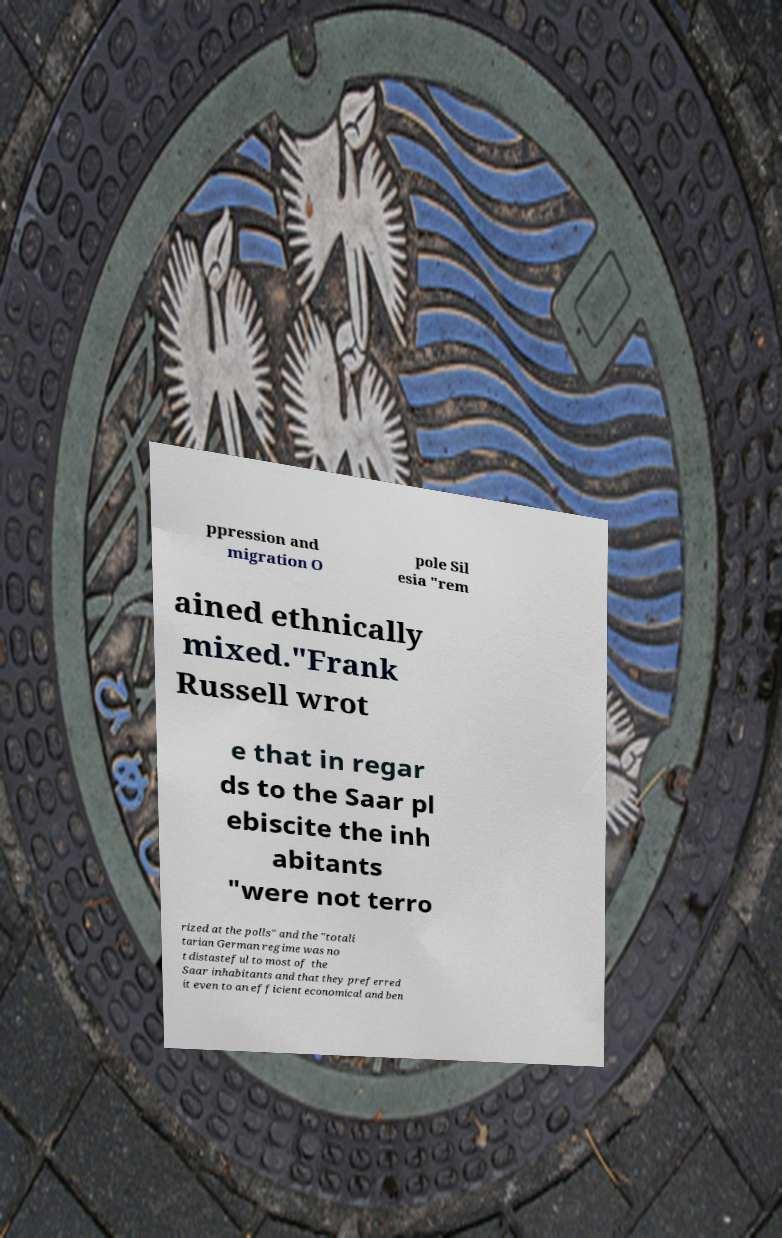Can you read and provide the text displayed in the image?This photo seems to have some interesting text. Can you extract and type it out for me? ppression and migration O pole Sil esia "rem ained ethnically mixed."Frank Russell wrot e that in regar ds to the Saar pl ebiscite the inh abitants "were not terro rized at the polls" and the "totali tarian German regime was no t distasteful to most of the Saar inhabitants and that they preferred it even to an efficient economical and ben 